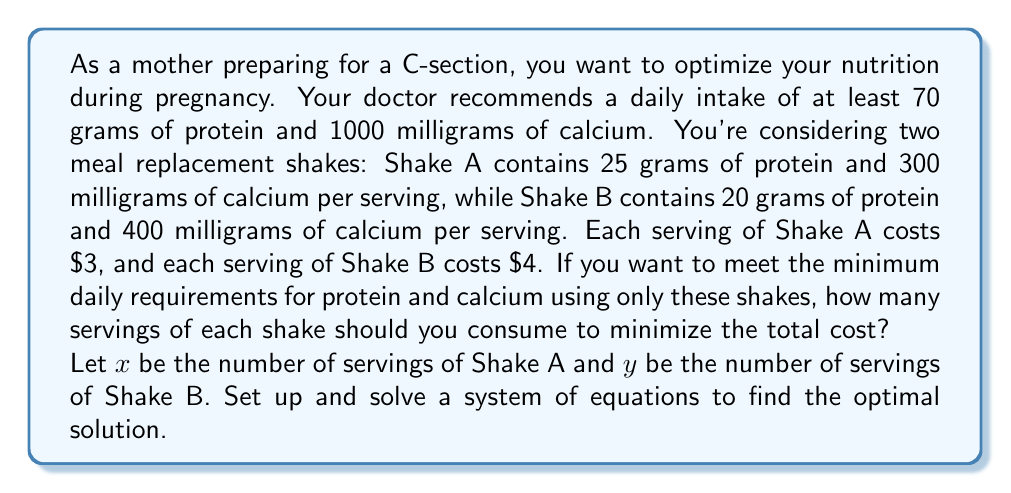Show me your answer to this math problem. Let's approach this problem step-by-step:

1. Set up the system of inequalities:
   For protein: $25x + 20y \geq 70$
   For calcium: $300x + 400y \geq 1000$
   
2. We want to minimize the cost function:
   $C = 3x + 4y$

3. To find the optimal solution, we need to solve the system of equations:
   $25x + 20y = 70$
   $300x + 400y = 1000$

4. Multiply the first equation by 12 to make the coefficients of $x$ equal:
   $300x + 240y = 840$
   $300x + 400y = 1000$

5. Subtract the first equation from the second:
   $160y = 160$
   $y = 1$

6. Substitute $y = 1$ into $25x + 20y = 70$:
   $25x + 20(1) = 70$
   $25x = 50$
   $x = 2$

7. Check if this solution satisfies both original inequalities:
   Protein: $25(2) + 20(1) = 70 \geq 70$ ✓
   Calcium: $300(2) + 400(1) = 1000 \geq 1000$ ✓

8. Calculate the total cost:
   $C = 3(2) + 4(1) = 10$

Therefore, the optimal solution is to consume 2 servings of Shake A and 1 serving of Shake B, which will meet the minimum requirements at a total cost of $10.
Answer: The optimal solution is to consume 2 servings of Shake A and 1 serving of Shake B, costing a total of $10. 